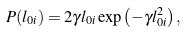Convert formula to latex. <formula><loc_0><loc_0><loc_500><loc_500>P ( l _ { 0 i } ) = 2 \gamma l _ { 0 i } \exp \left ( - \gamma l _ { 0 i } ^ { 2 } \right ) ,</formula> 